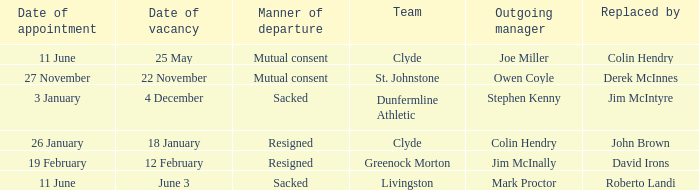Tell me the manner of departure for 3 january date of appointment Sacked. 